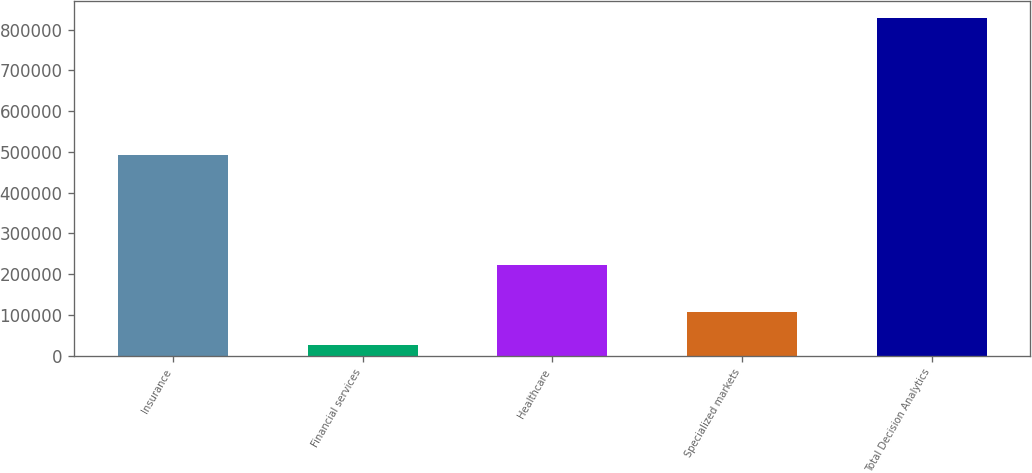Convert chart to OTSL. <chart><loc_0><loc_0><loc_500><loc_500><bar_chart><fcel>Insurance<fcel>Financial services<fcel>Healthcare<fcel>Specialized markets<fcel>Total Decision Analytics<nl><fcel>493456<fcel>26567<fcel>222955<fcel>106744<fcel>828342<nl></chart> 